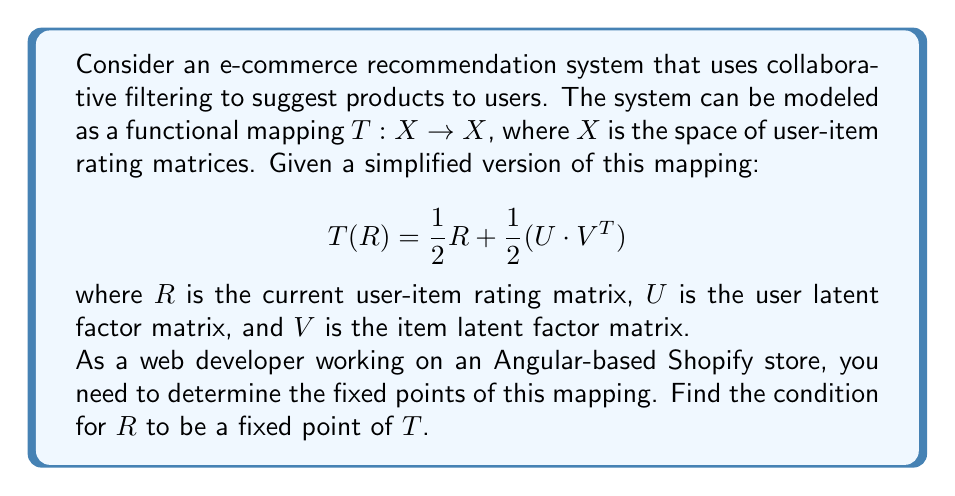Show me your answer to this math problem. To solve this problem, we need to understand the concept of fixed points in functional analysis and apply it to the given e-commerce recommendation system mapping.

1. A fixed point of a mapping $T: X \to X$ is an element $x \in X$ such that $T(x) = x$.

2. In our case, we're looking for a matrix $R$ such that $T(R) = R$.

3. Let's set up the equation:

   $T(R) = R$

4. Substitute the given mapping:

   $\frac{1}{2}R + \frac{1}{2}(U \cdot V^T) = R$

5. Subtract $\frac{1}{2}R$ from both sides:

   $\frac{1}{2}(U \cdot V^T) = \frac{1}{2}R$

6. Multiply both sides by 2:

   $U \cdot V^T = R$

This result shows that for $R$ to be a fixed point of the mapping $T$, it must be equal to the product of the user latent factor matrix $U$ and the transpose of the item latent factor matrix $V$.

In the context of an e-commerce recommendation system for a Shopify store:
- $U$ represents the latent preferences of users
- $V$ represents the latent features of items
- $U \cdot V^T$ is the predicted rating matrix based on these latent factors

The fixed point condition implies that the recommendation system reaches equilibrium when the current rating matrix $R$ exactly matches the predicted ratings based on the latent factor matrices.
Answer: The condition for $R$ to be a fixed point of the mapping $T$ is:

$$R = U \cdot V^T$$

where $U$ is the user latent factor matrix and $V$ is the item latent factor matrix. 